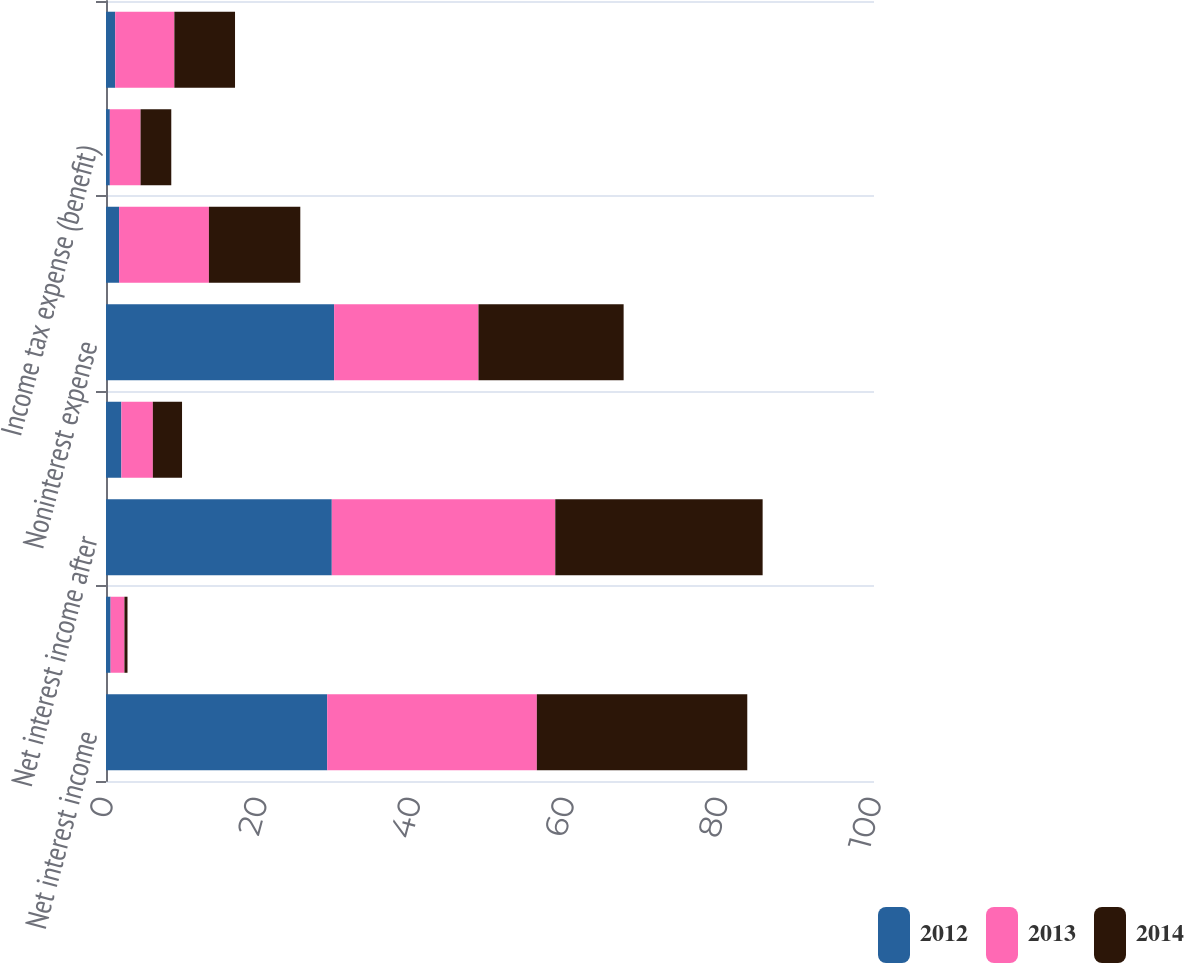Convert chart to OTSL. <chart><loc_0><loc_0><loc_500><loc_500><stacked_bar_chart><ecel><fcel>Net interest income<fcel>Provision for loan losses<fcel>Net interest income after<fcel>Other noninterest income<fcel>Noninterest expense<fcel>Income (loss) before income<fcel>Income tax expense (benefit)<fcel>Income (loss)<nl><fcel>2012<fcel>28.8<fcel>0.6<fcel>29.4<fcel>2<fcel>29.7<fcel>1.7<fcel>0.5<fcel>1.2<nl><fcel>2013<fcel>27.3<fcel>1.8<fcel>29.1<fcel>4.1<fcel>18.8<fcel>11.7<fcel>4<fcel>7.7<nl><fcel>2014<fcel>27.4<fcel>0.4<fcel>27<fcel>3.8<fcel>18.9<fcel>11.9<fcel>4<fcel>7.9<nl></chart> 